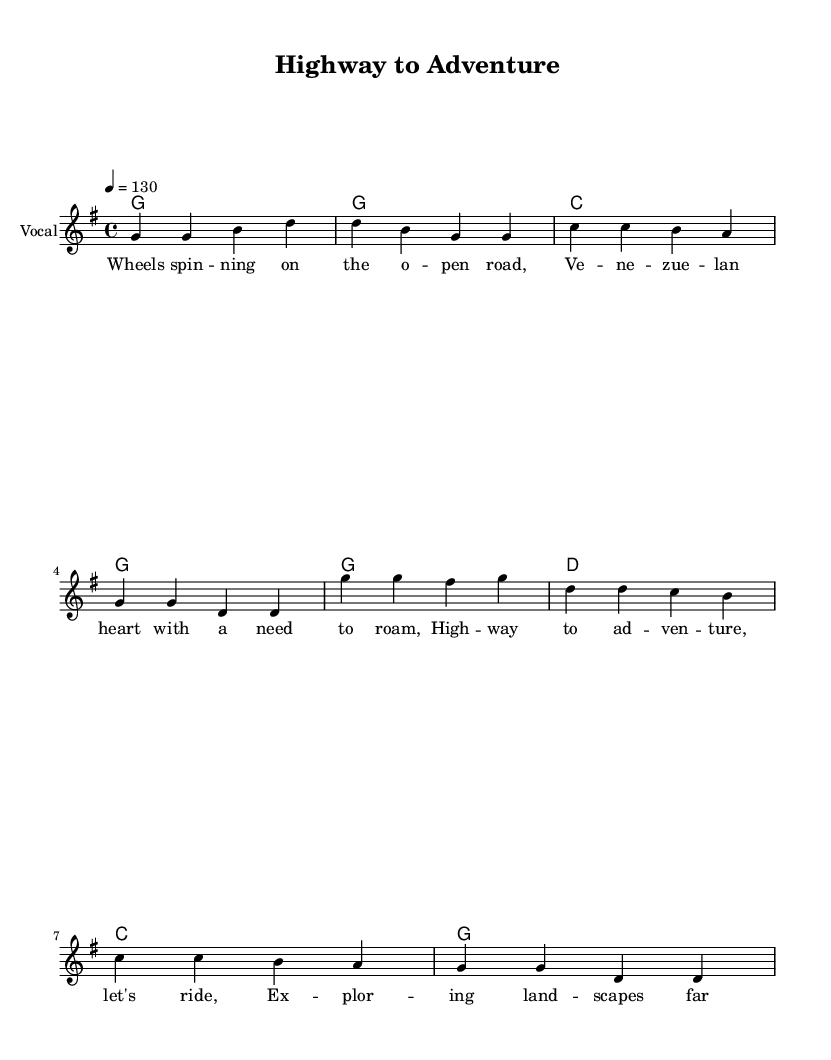What is the key signature of this music? The key signature is G major, which has one sharp. This is indicated at the beginning of the sheet music.
Answer: G major What is the time signature of this music? The time signature is 4/4, which means there are four beats in each measure and a quarter note gets one beat. This is indicated at the beginning of the sheet music.
Answer: 4/4 What is the tempo marking for this piece? The tempo marking indicates a speed of 130 beats per minute, specified by the tempo notation at the top of the music.
Answer: 130 How many measures are in the verse section? The verse section consists of four measures, as indicated by the rhythm in the melody line before the chorus begins.
Answer: 4 What instrument is indicated for the melody? The melody is indicated for vocal, as mentioned in the staff name at the beginning of the vocal line.
Answer: Vocal What thematic element is reflected in the lyrics? The lyrics reflect a sense of adventure and exploration, emphasizing themes of travel and discovery in unfamiliar landscapes.
Answer: Adventure How does the chorus differ in terms of melody compared to the verse? The chorus features a slightly different melodic line, which includes higher pitches and a more uplifting feel, typical of country rock choruses, providing contrast to the verse melody.
Answer: Higher pitches 